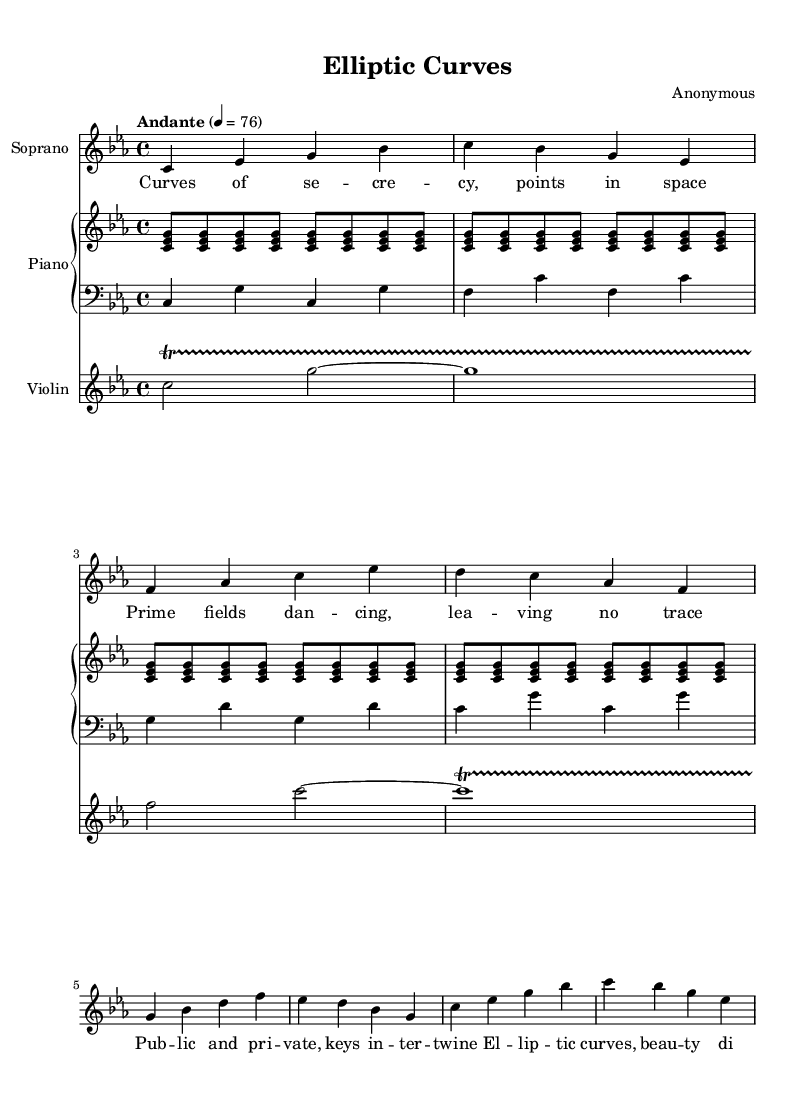What is the key signature of this music? The key signature is indicated at the beginning of the staff, showing that there are three flats, which corresponds to the key of C minor.
Answer: C minor What is the time signature of this music? The time signature is located near the beginning of the score as a fraction indicating four beats in a measure, which means it is in four-four time.
Answer: 4/4 What is the tempo marking for this piece? The tempo is indicated at the beginning of the score as "Andante," suggesting a moderate pace.
Answer: Andante How many measures are in the soprano part? By counting the groups of notes and rests in the soprano voice, we find there are eight measures in total.
Answer: Eight What instruments are included in this score? The instruments listed in the score are specifically mentioned at the beginning: Soprano, Piano, and Violin.
Answer: Soprano, Piano, Violin What is the dynamic marking for the piano part? There is no explicit dynamic marking provided in the provided code; therefore, we can infer it defaults to mezzo-forte unless noted otherwise.
Answer: Mezzo-forte What is the theme of the lyrics sung by the soprano? By examining the lyrics, we can identify the theme revolves around cryptographic concepts such as curves, fields, and keys.
Answer: Cryptography 